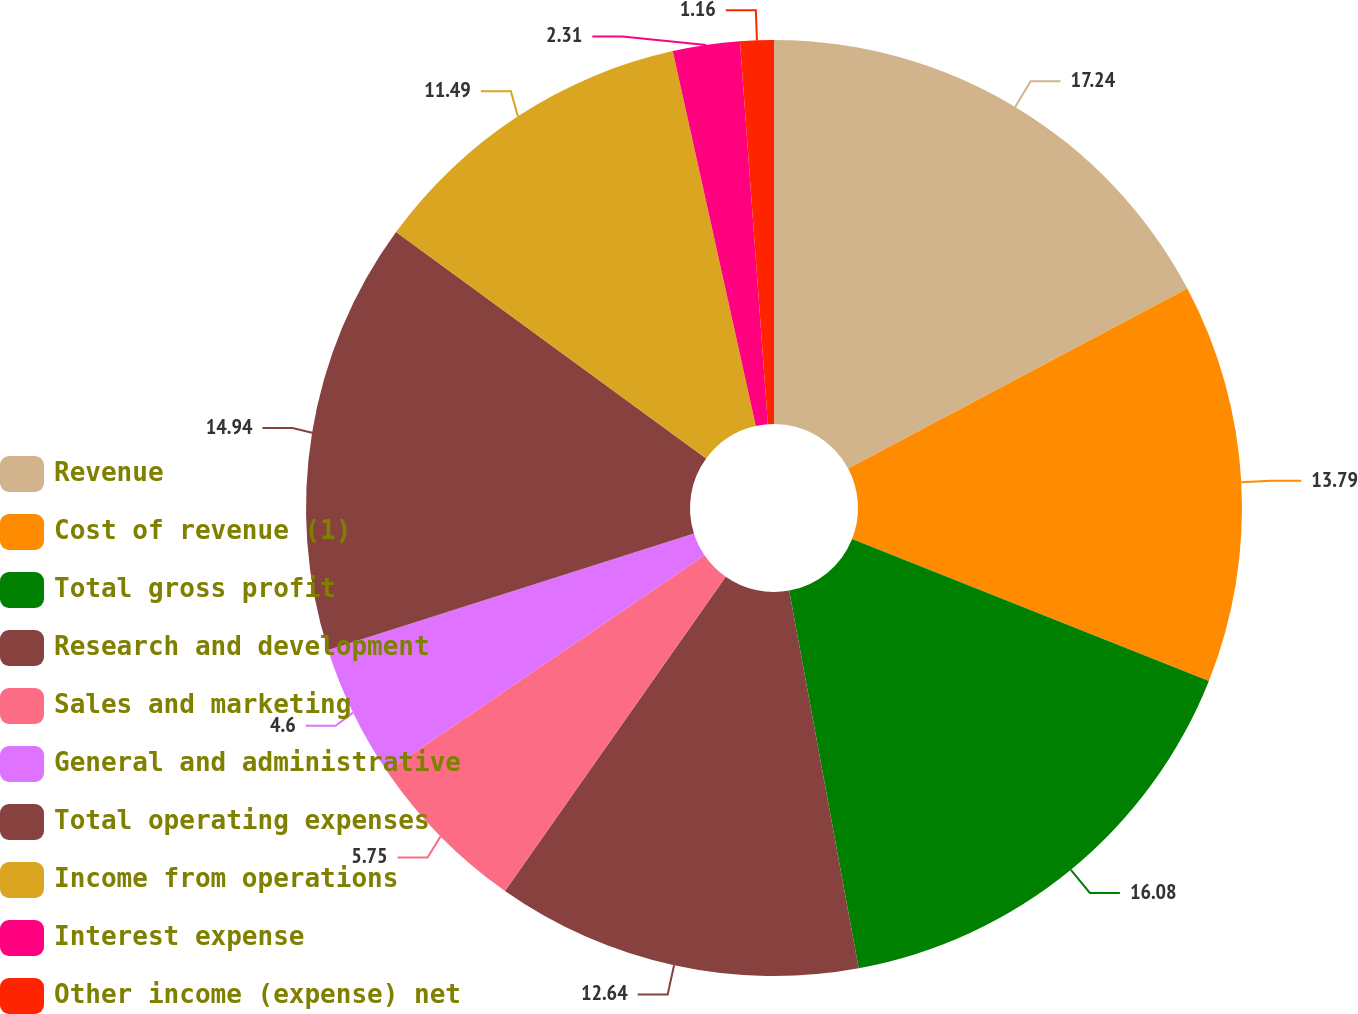Convert chart to OTSL. <chart><loc_0><loc_0><loc_500><loc_500><pie_chart><fcel>Revenue<fcel>Cost of revenue (1)<fcel>Total gross profit<fcel>Research and development<fcel>Sales and marketing<fcel>General and administrative<fcel>Total operating expenses<fcel>Income from operations<fcel>Interest expense<fcel>Other income (expense) net<nl><fcel>17.23%<fcel>13.79%<fcel>16.08%<fcel>12.64%<fcel>5.75%<fcel>4.6%<fcel>14.94%<fcel>11.49%<fcel>2.31%<fcel>1.16%<nl></chart> 